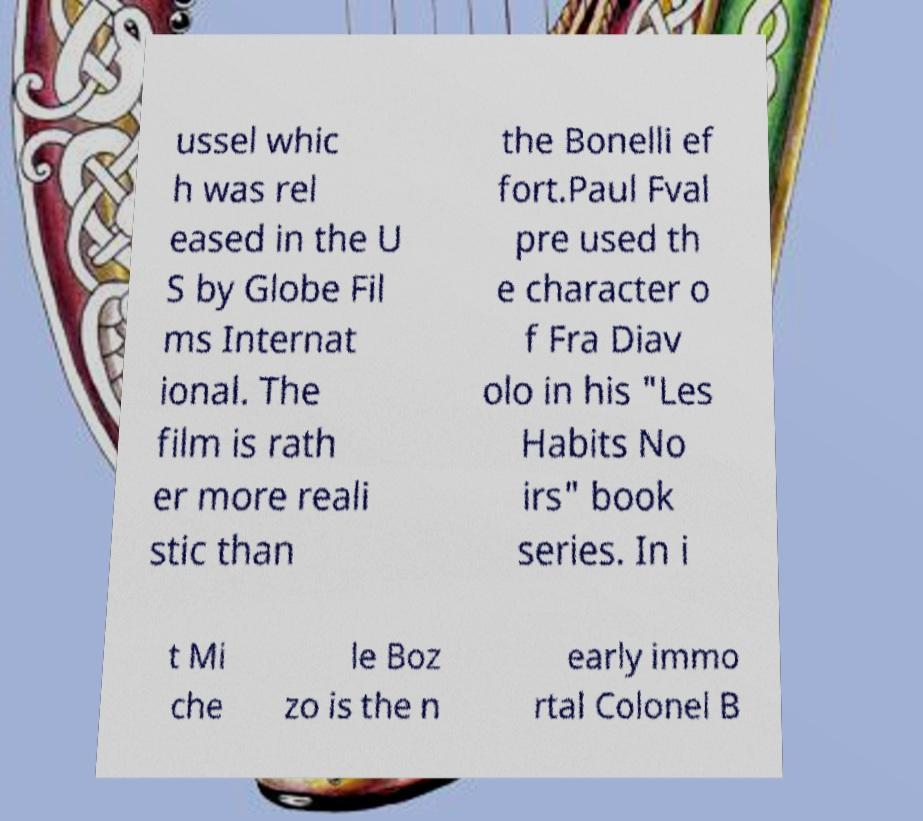Could you assist in decoding the text presented in this image and type it out clearly? ussel whic h was rel eased in the U S by Globe Fil ms Internat ional. The film is rath er more reali stic than the Bonelli ef fort.Paul Fval pre used th e character o f Fra Diav olo in his "Les Habits No irs" book series. In i t Mi che le Boz zo is the n early immo rtal Colonel B 